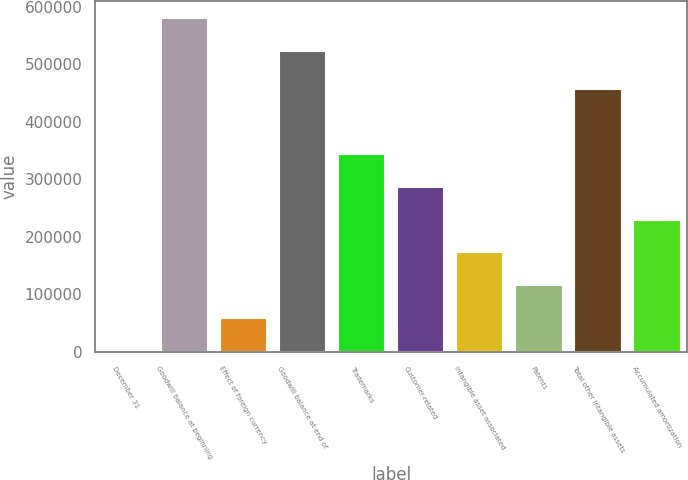Convert chart to OTSL. <chart><loc_0><loc_0><loc_500><loc_500><bar_chart><fcel>December 31<fcel>Goodwill balance at beginning<fcel>Effect of foreign currency<fcel>Goodwill balance at end of<fcel>Trademarks<fcel>Customer-related<fcel>Intangible asset associated<fcel>Patents<fcel>Total other intangible assets<fcel>Accumulated amortization<nl><fcel>2010<fcel>581091<fcel>58967<fcel>524134<fcel>343752<fcel>286795<fcel>172881<fcel>115924<fcel>457666<fcel>229838<nl></chart> 